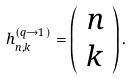Convert formula to latex. <formula><loc_0><loc_0><loc_500><loc_500>h _ { n , k } ^ { ( q \rightarrow 1 ) } = \left ( \begin{array} { c } n \\ k \end{array} \right ) .</formula> 